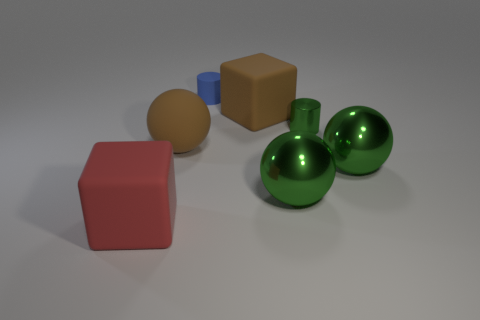Subtract all large brown spheres. How many spheres are left? 2 Subtract all blue cylinders. How many cylinders are left? 1 Subtract 2 cubes. How many cubes are left? 0 Subtract all blue cylinders. Subtract all green metal spheres. How many objects are left? 4 Add 5 blocks. How many blocks are left? 7 Add 4 yellow objects. How many yellow objects exist? 4 Add 3 blue spheres. How many objects exist? 10 Subtract 0 purple spheres. How many objects are left? 7 Subtract all cylinders. How many objects are left? 5 Subtract all brown cylinders. Subtract all cyan balls. How many cylinders are left? 2 